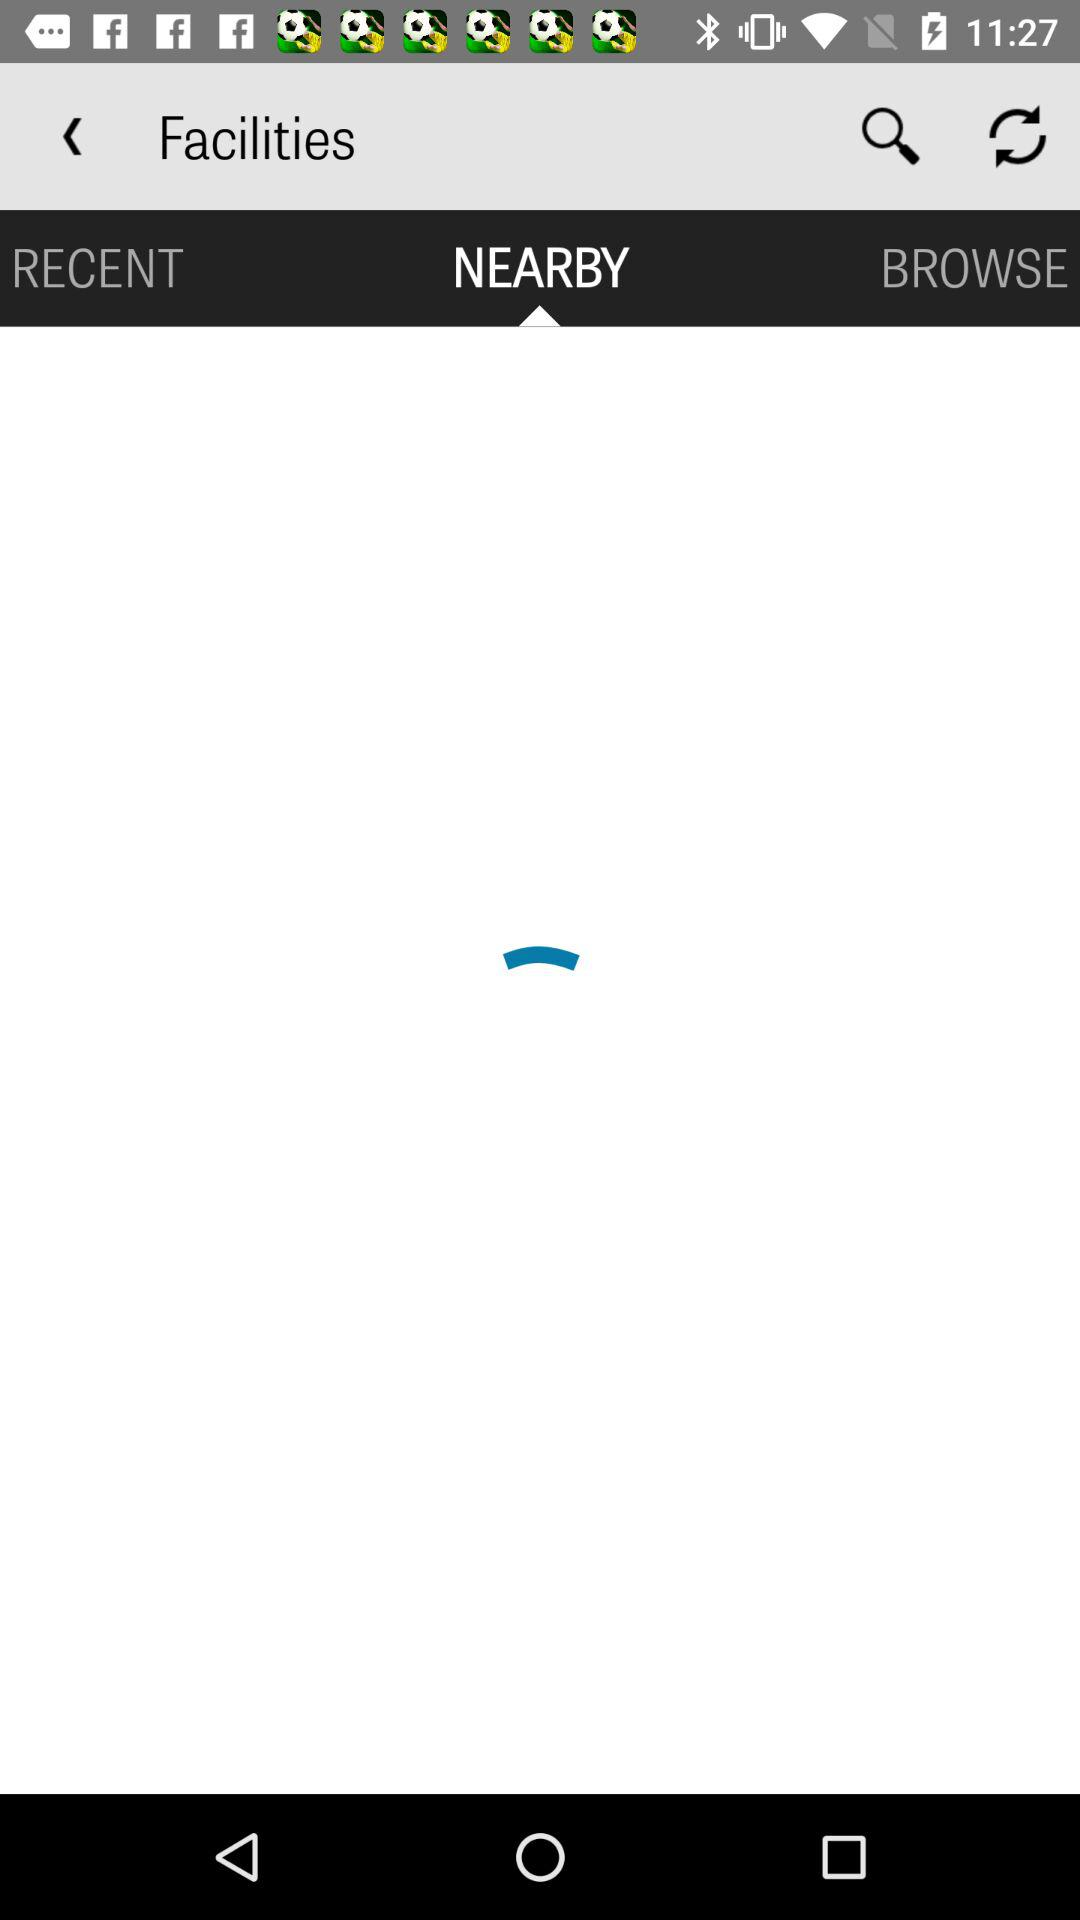Which tab is selected? The selected tab is "NEARBY". 